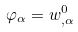<formula> <loc_0><loc_0><loc_500><loc_500>\varphi _ { \alpha } = w _ { , \alpha } ^ { 0 }</formula> 